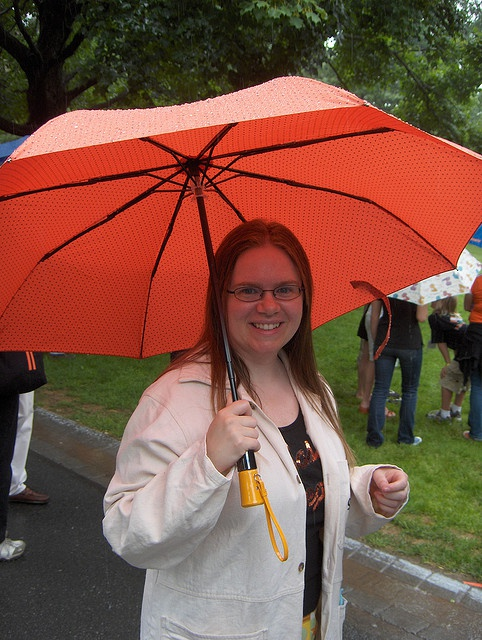Describe the objects in this image and their specific colors. I can see umbrella in darkgreen, red, brown, and lightpink tones, people in darkgreen, darkgray, pink, black, and maroon tones, people in darkgreen, black, maroon, and gray tones, people in darkgreen, black, darkgray, gray, and maroon tones, and people in darkgreen, black, and gray tones in this image. 